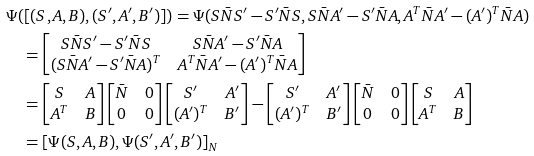<formula> <loc_0><loc_0><loc_500><loc_500>& \Psi ( [ ( S , A , B ) , ( S ^ { \prime } , A ^ { \prime } , B ^ { \prime } ) ] ) = \Psi ( S \bar { N } S ^ { \prime } - S ^ { \prime } \bar { N } S , S \bar { N } A ^ { \prime } - S ^ { \prime } \bar { N } A , A ^ { T } \bar { N } A ^ { \prime } - ( A ^ { \prime } ) ^ { T } \bar { N } A ) \\ & \quad = \begin{bmatrix} S \bar { N } S ^ { \prime } - S ^ { \prime } \bar { N } S & S \bar { N } A ^ { \prime } - S ^ { \prime } \bar { N } A \\ ( S \bar { N } A ^ { \prime } - S ^ { \prime } \bar { N } A ) ^ { T } & A ^ { T } \bar { N } A ^ { \prime } - ( A ^ { \prime } ) ^ { T } \bar { N } A \end{bmatrix} \\ & \quad = \begin{bmatrix} S & A \\ A ^ { T } & B \end{bmatrix} \begin{bmatrix} \bar { N } & 0 \\ 0 & 0 \end{bmatrix} \begin{bmatrix} S ^ { \prime } & A ^ { \prime } \\ ( A ^ { \prime } ) ^ { T } & B ^ { \prime } \end{bmatrix} - \begin{bmatrix} S ^ { \prime } & A ^ { \prime } \\ ( A ^ { \prime } ) ^ { T } & B ^ { \prime } \end{bmatrix} \begin{bmatrix} \bar { N } & 0 \\ 0 & 0 \end{bmatrix} \begin{bmatrix} S & A \\ A ^ { T } & B \end{bmatrix} \\ & \quad = [ \Psi ( S , A , B ) , \Psi ( S ^ { \prime } , A ^ { \prime } , B ^ { \prime } ) ] _ { N }</formula> 